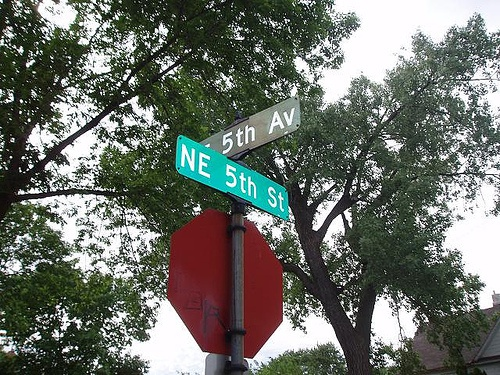Describe the objects in this image and their specific colors. I can see a stop sign in white, maroon, black, gray, and brown tones in this image. 